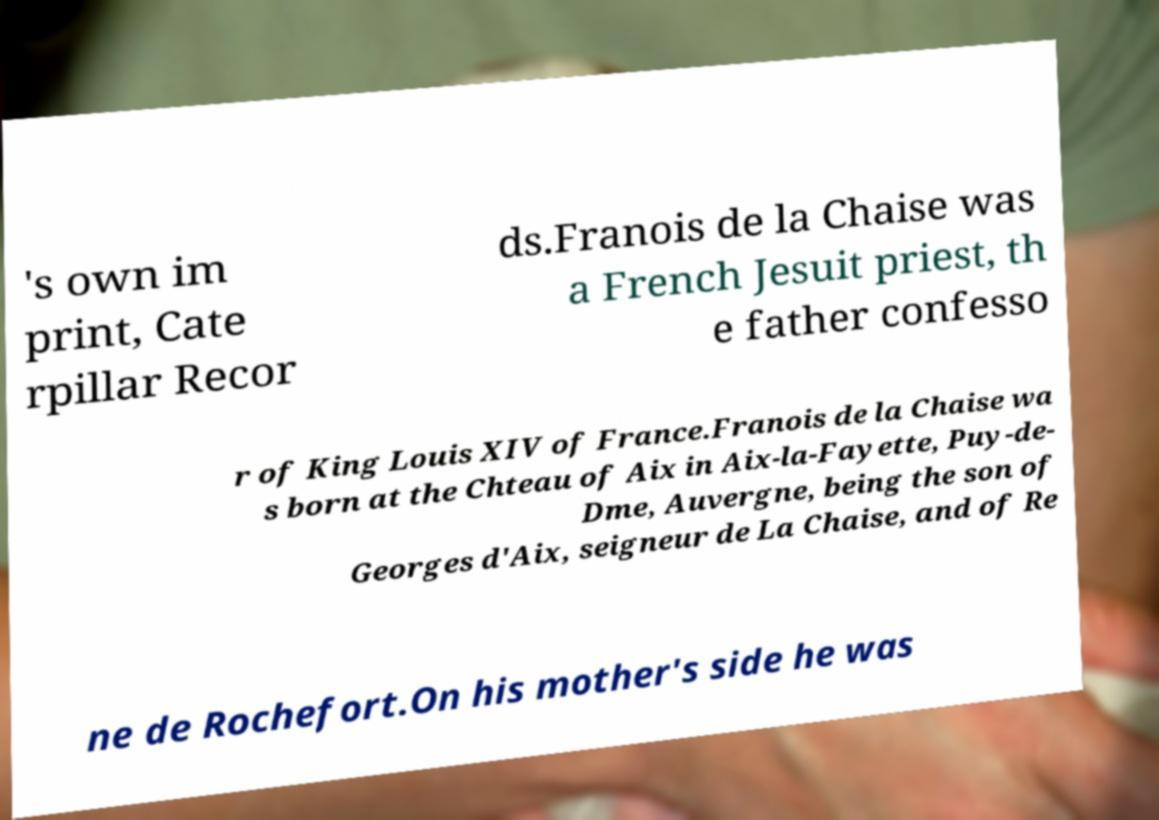What messages or text are displayed in this image? I need them in a readable, typed format. 's own im print, Cate rpillar Recor ds.Franois de la Chaise was a French Jesuit priest, th e father confesso r of King Louis XIV of France.Franois de la Chaise wa s born at the Chteau of Aix in Aix-la-Fayette, Puy-de- Dme, Auvergne, being the son of Georges d'Aix, seigneur de La Chaise, and of Re ne de Rochefort.On his mother's side he was 